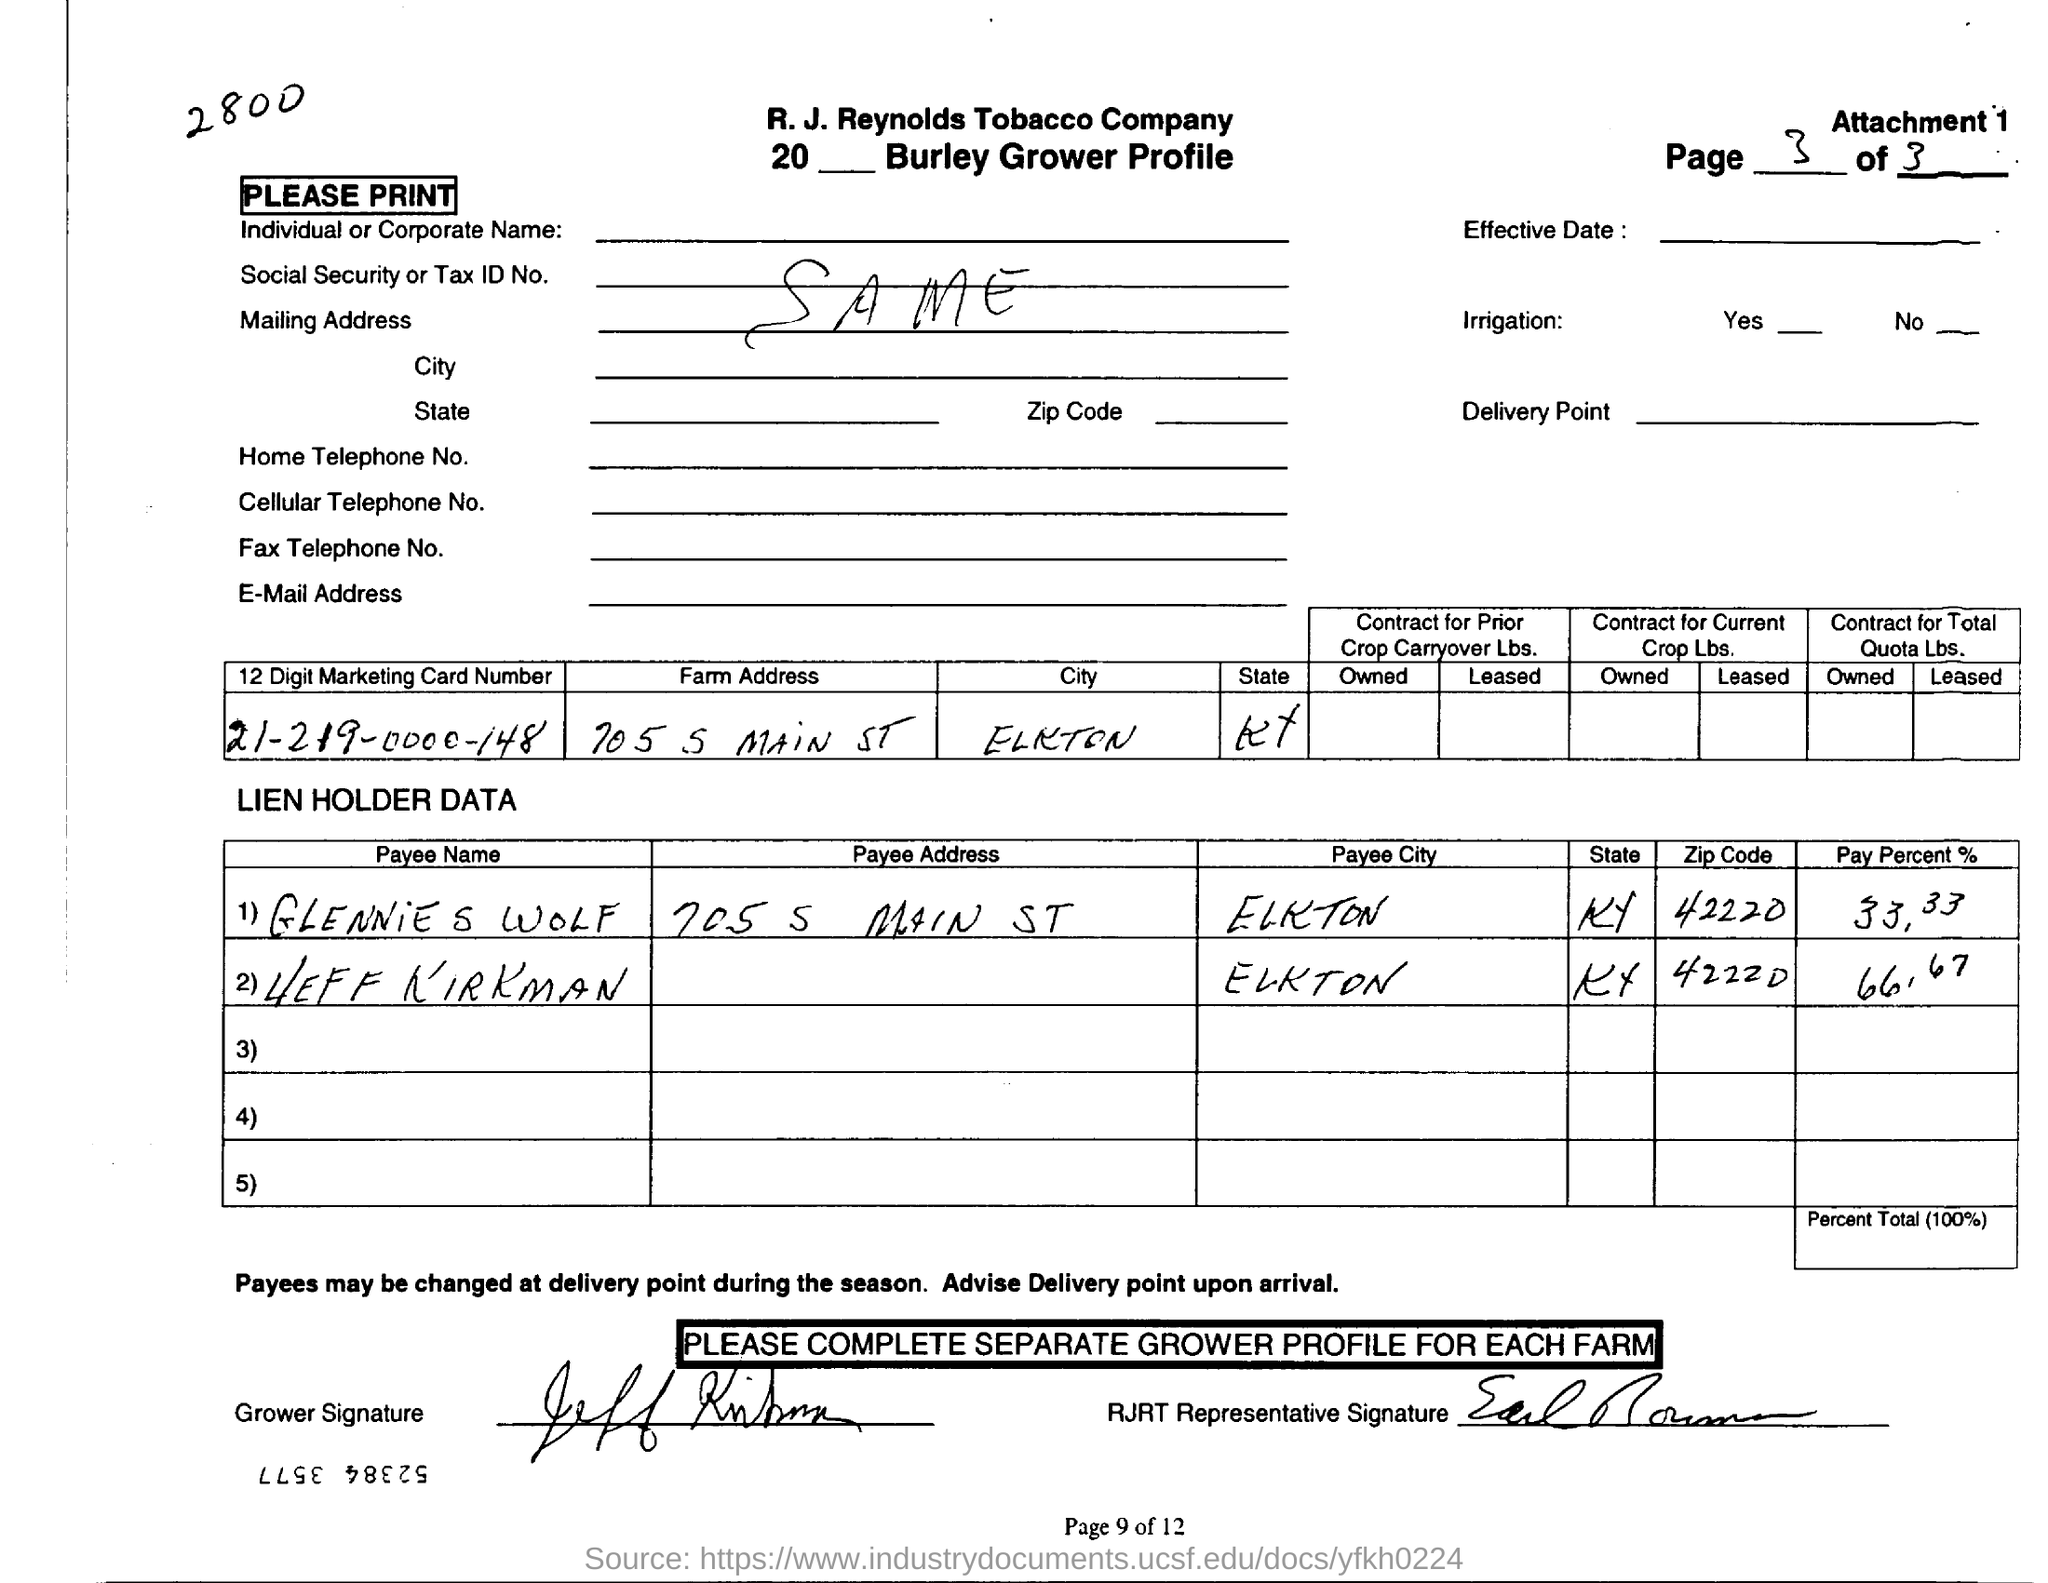What is the 12 digit marketing Card number?
Make the answer very short. 21-219-0000-148. 